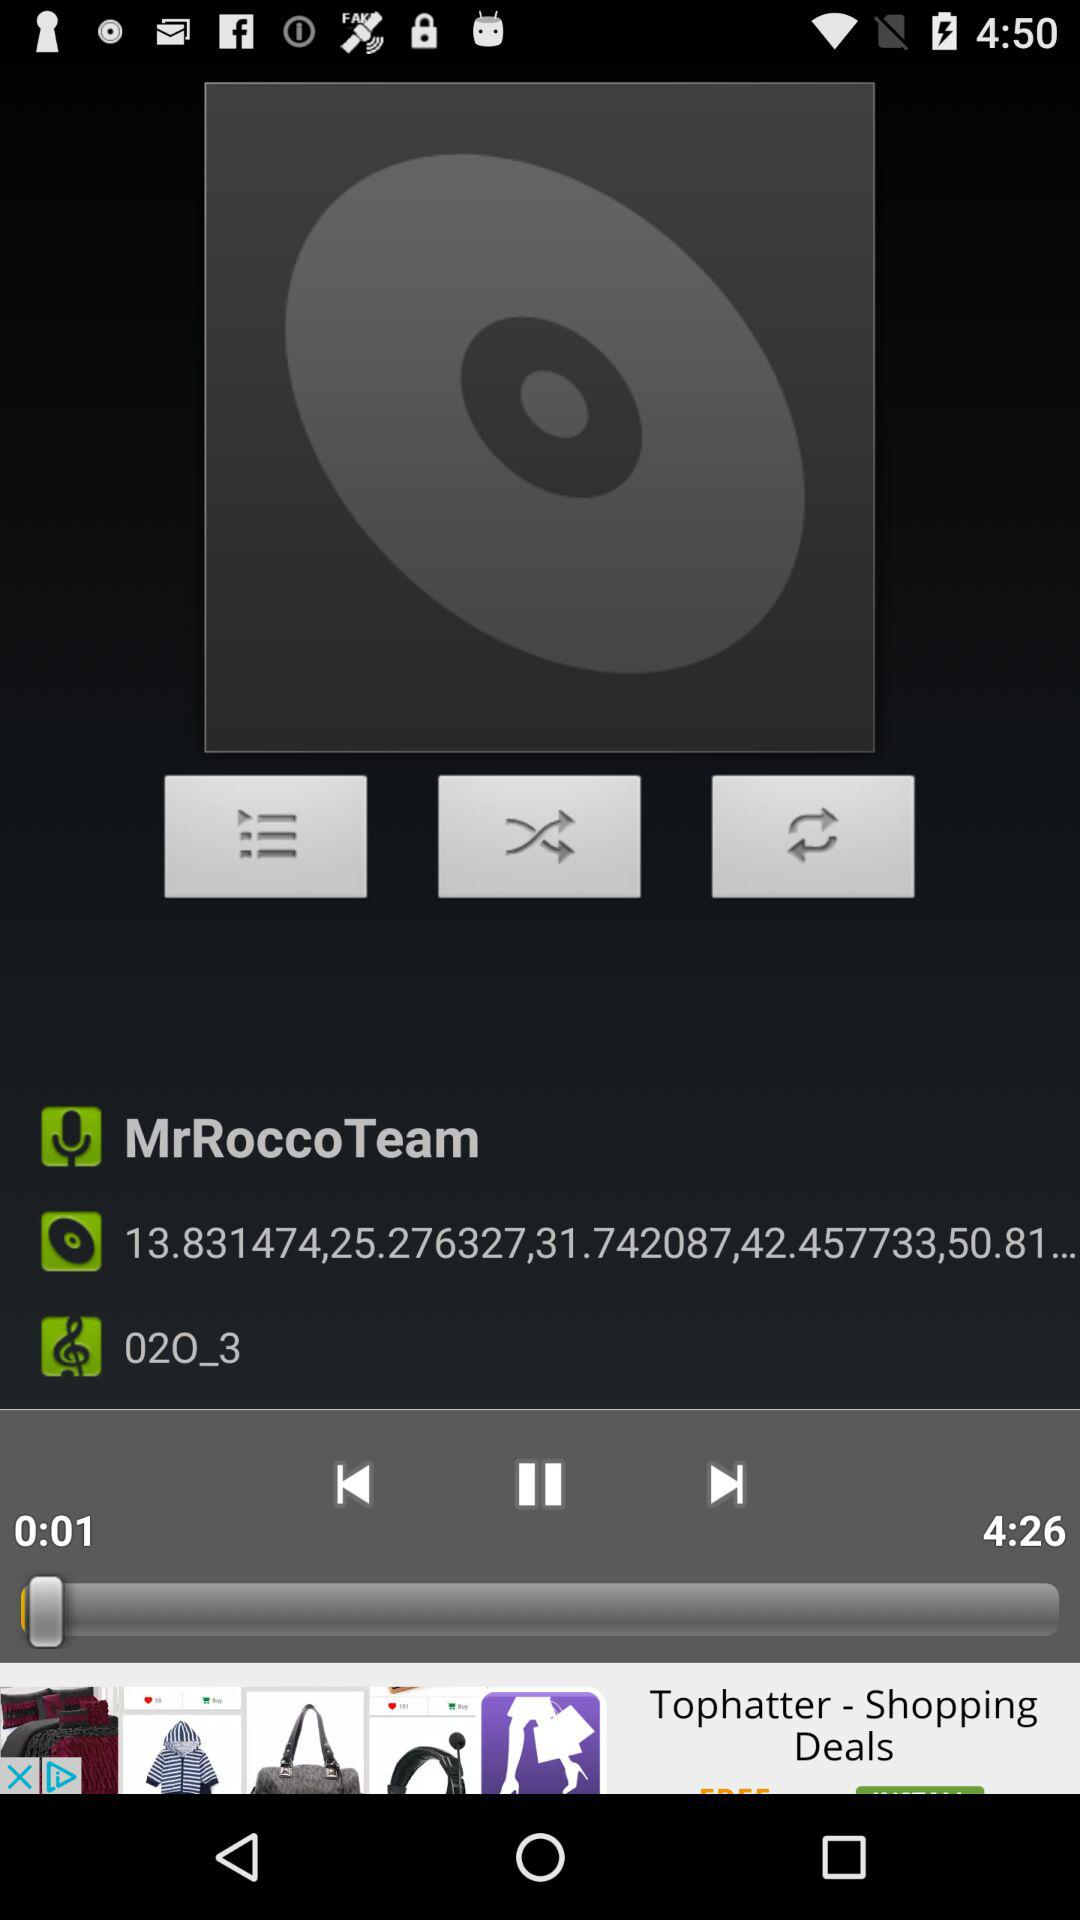Which audio is playing? The audio that is playing is "02O_3". 